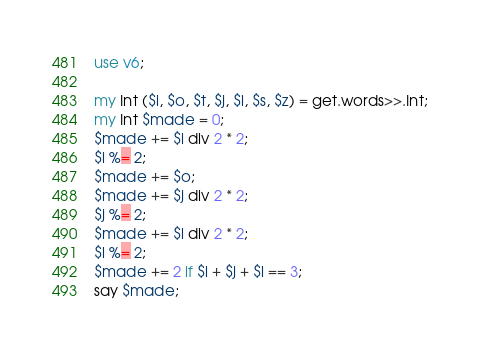<code> <loc_0><loc_0><loc_500><loc_500><_Perl_>use v6;

my Int ($i, $o, $t, $j, $l, $s, $z) = get.words>>.Int;
my Int $made = 0;
$made += $i div 2 * 2;
$i %= 2;
$made += $o;
$made += $j div 2 * 2;
$j %= 2;
$made += $l div 2 * 2;
$l %= 2;
$made += 2 if $i + $j + $l == 3;
say $made;
</code> 